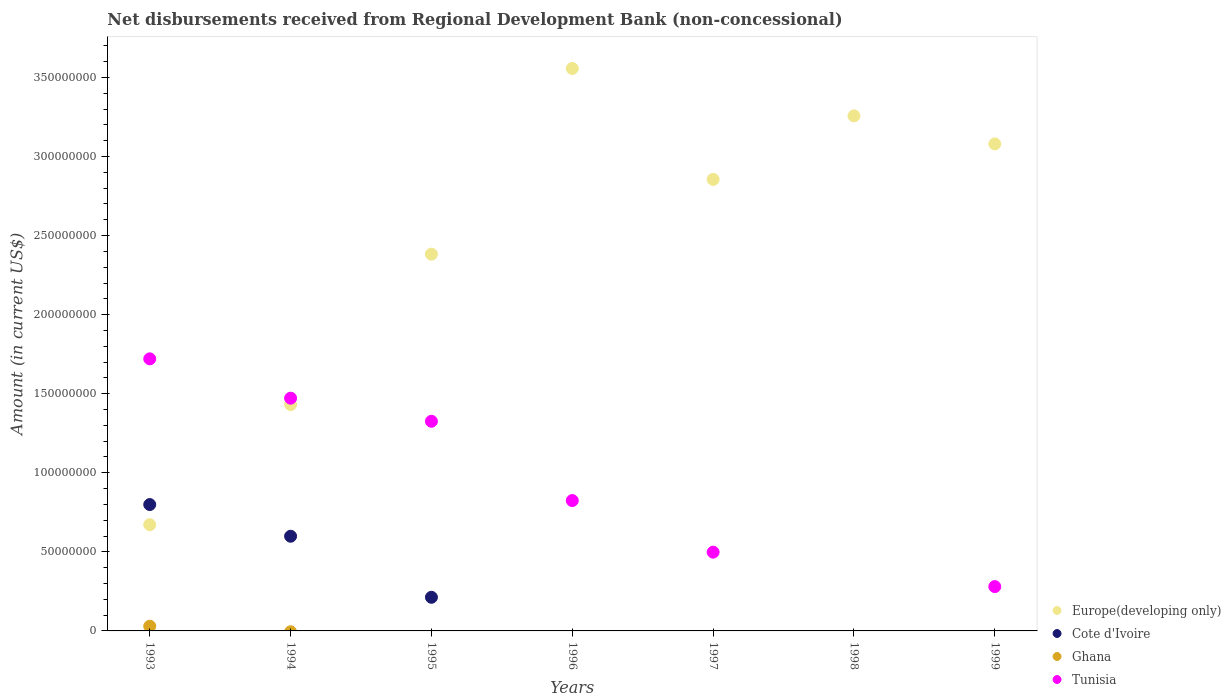Across all years, what is the maximum amount of disbursements received from Regional Development Bank in Ghana?
Your answer should be very brief. 2.98e+06. In which year was the amount of disbursements received from Regional Development Bank in Europe(developing only) maximum?
Provide a succinct answer. 1996. What is the total amount of disbursements received from Regional Development Bank in Cote d'Ivoire in the graph?
Give a very brief answer. 1.61e+08. What is the difference between the amount of disbursements received from Regional Development Bank in Europe(developing only) in 1994 and that in 1999?
Provide a succinct answer. -1.65e+08. What is the difference between the amount of disbursements received from Regional Development Bank in Cote d'Ivoire in 1993 and the amount of disbursements received from Regional Development Bank in Tunisia in 1997?
Ensure brevity in your answer.  3.01e+07. What is the average amount of disbursements received from Regional Development Bank in Tunisia per year?
Offer a terse response. 8.74e+07. In the year 1993, what is the difference between the amount of disbursements received from Regional Development Bank in Cote d'Ivoire and amount of disbursements received from Regional Development Bank in Ghana?
Offer a terse response. 7.69e+07. What is the ratio of the amount of disbursements received from Regional Development Bank in Europe(developing only) in 1997 to that in 1998?
Make the answer very short. 0.88. What is the difference between the highest and the second highest amount of disbursements received from Regional Development Bank in Tunisia?
Provide a short and direct response. 2.49e+07. What is the difference between the highest and the lowest amount of disbursements received from Regional Development Bank in Cote d'Ivoire?
Offer a very short reply. 7.99e+07. In how many years, is the amount of disbursements received from Regional Development Bank in Ghana greater than the average amount of disbursements received from Regional Development Bank in Ghana taken over all years?
Your answer should be very brief. 1. Is the sum of the amount of disbursements received from Regional Development Bank in Europe(developing only) in 1995 and 1999 greater than the maximum amount of disbursements received from Regional Development Bank in Tunisia across all years?
Your answer should be compact. Yes. Does the amount of disbursements received from Regional Development Bank in Ghana monotonically increase over the years?
Offer a terse response. No. Is the amount of disbursements received from Regional Development Bank in Ghana strictly less than the amount of disbursements received from Regional Development Bank in Tunisia over the years?
Provide a short and direct response. No. How many years are there in the graph?
Keep it short and to the point. 7. Are the values on the major ticks of Y-axis written in scientific E-notation?
Provide a short and direct response. No. Does the graph contain grids?
Offer a very short reply. No. Where does the legend appear in the graph?
Your answer should be compact. Bottom right. How many legend labels are there?
Keep it short and to the point. 4. What is the title of the graph?
Make the answer very short. Net disbursements received from Regional Development Bank (non-concessional). What is the label or title of the X-axis?
Provide a succinct answer. Years. What is the label or title of the Y-axis?
Your response must be concise. Amount (in current US$). What is the Amount (in current US$) in Europe(developing only) in 1993?
Offer a terse response. 6.72e+07. What is the Amount (in current US$) in Cote d'Ivoire in 1993?
Your answer should be very brief. 7.99e+07. What is the Amount (in current US$) in Ghana in 1993?
Provide a succinct answer. 2.98e+06. What is the Amount (in current US$) in Tunisia in 1993?
Make the answer very short. 1.72e+08. What is the Amount (in current US$) of Europe(developing only) in 1994?
Your answer should be very brief. 1.43e+08. What is the Amount (in current US$) of Cote d'Ivoire in 1994?
Offer a very short reply. 5.99e+07. What is the Amount (in current US$) of Tunisia in 1994?
Make the answer very short. 1.47e+08. What is the Amount (in current US$) of Europe(developing only) in 1995?
Provide a succinct answer. 2.38e+08. What is the Amount (in current US$) of Cote d'Ivoire in 1995?
Your response must be concise. 2.13e+07. What is the Amount (in current US$) of Ghana in 1995?
Offer a terse response. 0. What is the Amount (in current US$) in Tunisia in 1995?
Offer a terse response. 1.33e+08. What is the Amount (in current US$) in Europe(developing only) in 1996?
Make the answer very short. 3.56e+08. What is the Amount (in current US$) of Ghana in 1996?
Keep it short and to the point. 0. What is the Amount (in current US$) of Tunisia in 1996?
Provide a succinct answer. 8.24e+07. What is the Amount (in current US$) of Europe(developing only) in 1997?
Offer a terse response. 2.86e+08. What is the Amount (in current US$) in Cote d'Ivoire in 1997?
Keep it short and to the point. 0. What is the Amount (in current US$) in Ghana in 1997?
Your answer should be very brief. 0. What is the Amount (in current US$) in Tunisia in 1997?
Provide a succinct answer. 4.98e+07. What is the Amount (in current US$) of Europe(developing only) in 1998?
Offer a very short reply. 3.26e+08. What is the Amount (in current US$) in Cote d'Ivoire in 1998?
Offer a terse response. 0. What is the Amount (in current US$) of Europe(developing only) in 1999?
Your response must be concise. 3.08e+08. What is the Amount (in current US$) in Cote d'Ivoire in 1999?
Keep it short and to the point. 0. What is the Amount (in current US$) of Tunisia in 1999?
Your answer should be compact. 2.80e+07. Across all years, what is the maximum Amount (in current US$) of Europe(developing only)?
Ensure brevity in your answer.  3.56e+08. Across all years, what is the maximum Amount (in current US$) of Cote d'Ivoire?
Offer a very short reply. 7.99e+07. Across all years, what is the maximum Amount (in current US$) of Ghana?
Provide a short and direct response. 2.98e+06. Across all years, what is the maximum Amount (in current US$) in Tunisia?
Give a very brief answer. 1.72e+08. Across all years, what is the minimum Amount (in current US$) in Europe(developing only)?
Offer a very short reply. 6.72e+07. What is the total Amount (in current US$) in Europe(developing only) in the graph?
Provide a succinct answer. 1.72e+09. What is the total Amount (in current US$) of Cote d'Ivoire in the graph?
Give a very brief answer. 1.61e+08. What is the total Amount (in current US$) in Ghana in the graph?
Ensure brevity in your answer.  2.98e+06. What is the total Amount (in current US$) in Tunisia in the graph?
Your answer should be very brief. 6.12e+08. What is the difference between the Amount (in current US$) in Europe(developing only) in 1993 and that in 1994?
Provide a short and direct response. -7.60e+07. What is the difference between the Amount (in current US$) in Cote d'Ivoire in 1993 and that in 1994?
Provide a succinct answer. 2.00e+07. What is the difference between the Amount (in current US$) in Tunisia in 1993 and that in 1994?
Keep it short and to the point. 2.49e+07. What is the difference between the Amount (in current US$) of Europe(developing only) in 1993 and that in 1995?
Your answer should be very brief. -1.71e+08. What is the difference between the Amount (in current US$) of Cote d'Ivoire in 1993 and that in 1995?
Make the answer very short. 5.86e+07. What is the difference between the Amount (in current US$) of Tunisia in 1993 and that in 1995?
Keep it short and to the point. 3.95e+07. What is the difference between the Amount (in current US$) in Europe(developing only) in 1993 and that in 1996?
Keep it short and to the point. -2.88e+08. What is the difference between the Amount (in current US$) in Tunisia in 1993 and that in 1996?
Keep it short and to the point. 8.96e+07. What is the difference between the Amount (in current US$) of Europe(developing only) in 1993 and that in 1997?
Your answer should be compact. -2.18e+08. What is the difference between the Amount (in current US$) of Tunisia in 1993 and that in 1997?
Offer a terse response. 1.22e+08. What is the difference between the Amount (in current US$) in Europe(developing only) in 1993 and that in 1998?
Provide a short and direct response. -2.59e+08. What is the difference between the Amount (in current US$) of Europe(developing only) in 1993 and that in 1999?
Keep it short and to the point. -2.41e+08. What is the difference between the Amount (in current US$) of Tunisia in 1993 and that in 1999?
Provide a short and direct response. 1.44e+08. What is the difference between the Amount (in current US$) in Europe(developing only) in 1994 and that in 1995?
Your answer should be compact. -9.51e+07. What is the difference between the Amount (in current US$) of Cote d'Ivoire in 1994 and that in 1995?
Your answer should be very brief. 3.86e+07. What is the difference between the Amount (in current US$) in Tunisia in 1994 and that in 1995?
Keep it short and to the point. 1.46e+07. What is the difference between the Amount (in current US$) in Europe(developing only) in 1994 and that in 1996?
Your answer should be compact. -2.13e+08. What is the difference between the Amount (in current US$) of Tunisia in 1994 and that in 1996?
Ensure brevity in your answer.  6.47e+07. What is the difference between the Amount (in current US$) in Europe(developing only) in 1994 and that in 1997?
Give a very brief answer. -1.42e+08. What is the difference between the Amount (in current US$) of Tunisia in 1994 and that in 1997?
Offer a very short reply. 9.74e+07. What is the difference between the Amount (in current US$) of Europe(developing only) in 1994 and that in 1998?
Offer a very short reply. -1.83e+08. What is the difference between the Amount (in current US$) of Europe(developing only) in 1994 and that in 1999?
Give a very brief answer. -1.65e+08. What is the difference between the Amount (in current US$) of Tunisia in 1994 and that in 1999?
Ensure brevity in your answer.  1.19e+08. What is the difference between the Amount (in current US$) in Europe(developing only) in 1995 and that in 1996?
Keep it short and to the point. -1.17e+08. What is the difference between the Amount (in current US$) in Tunisia in 1995 and that in 1996?
Give a very brief answer. 5.01e+07. What is the difference between the Amount (in current US$) in Europe(developing only) in 1995 and that in 1997?
Give a very brief answer. -4.73e+07. What is the difference between the Amount (in current US$) in Tunisia in 1995 and that in 1997?
Offer a terse response. 8.28e+07. What is the difference between the Amount (in current US$) of Europe(developing only) in 1995 and that in 1998?
Provide a short and direct response. -8.75e+07. What is the difference between the Amount (in current US$) of Europe(developing only) in 1995 and that in 1999?
Provide a short and direct response. -6.97e+07. What is the difference between the Amount (in current US$) in Tunisia in 1995 and that in 1999?
Make the answer very short. 1.05e+08. What is the difference between the Amount (in current US$) of Europe(developing only) in 1996 and that in 1997?
Ensure brevity in your answer.  7.01e+07. What is the difference between the Amount (in current US$) of Tunisia in 1996 and that in 1997?
Offer a very short reply. 3.26e+07. What is the difference between the Amount (in current US$) in Europe(developing only) in 1996 and that in 1998?
Ensure brevity in your answer.  3.00e+07. What is the difference between the Amount (in current US$) in Europe(developing only) in 1996 and that in 1999?
Your answer should be compact. 4.77e+07. What is the difference between the Amount (in current US$) in Tunisia in 1996 and that in 1999?
Offer a very short reply. 5.44e+07. What is the difference between the Amount (in current US$) in Europe(developing only) in 1997 and that in 1998?
Your answer should be compact. -4.02e+07. What is the difference between the Amount (in current US$) of Europe(developing only) in 1997 and that in 1999?
Offer a terse response. -2.24e+07. What is the difference between the Amount (in current US$) in Tunisia in 1997 and that in 1999?
Provide a short and direct response. 2.18e+07. What is the difference between the Amount (in current US$) in Europe(developing only) in 1998 and that in 1999?
Your answer should be compact. 1.77e+07. What is the difference between the Amount (in current US$) of Europe(developing only) in 1993 and the Amount (in current US$) of Cote d'Ivoire in 1994?
Give a very brief answer. 7.30e+06. What is the difference between the Amount (in current US$) in Europe(developing only) in 1993 and the Amount (in current US$) in Tunisia in 1994?
Offer a terse response. -8.00e+07. What is the difference between the Amount (in current US$) of Cote d'Ivoire in 1993 and the Amount (in current US$) of Tunisia in 1994?
Your answer should be very brief. -6.73e+07. What is the difference between the Amount (in current US$) of Ghana in 1993 and the Amount (in current US$) of Tunisia in 1994?
Your response must be concise. -1.44e+08. What is the difference between the Amount (in current US$) in Europe(developing only) in 1993 and the Amount (in current US$) in Cote d'Ivoire in 1995?
Offer a very short reply. 4.59e+07. What is the difference between the Amount (in current US$) of Europe(developing only) in 1993 and the Amount (in current US$) of Tunisia in 1995?
Offer a terse response. -6.54e+07. What is the difference between the Amount (in current US$) of Cote d'Ivoire in 1993 and the Amount (in current US$) of Tunisia in 1995?
Keep it short and to the point. -5.27e+07. What is the difference between the Amount (in current US$) in Ghana in 1993 and the Amount (in current US$) in Tunisia in 1995?
Make the answer very short. -1.30e+08. What is the difference between the Amount (in current US$) in Europe(developing only) in 1993 and the Amount (in current US$) in Tunisia in 1996?
Provide a short and direct response. -1.53e+07. What is the difference between the Amount (in current US$) of Cote d'Ivoire in 1993 and the Amount (in current US$) of Tunisia in 1996?
Make the answer very short. -2.53e+06. What is the difference between the Amount (in current US$) of Ghana in 1993 and the Amount (in current US$) of Tunisia in 1996?
Provide a succinct answer. -7.95e+07. What is the difference between the Amount (in current US$) in Europe(developing only) in 1993 and the Amount (in current US$) in Tunisia in 1997?
Give a very brief answer. 1.74e+07. What is the difference between the Amount (in current US$) in Cote d'Ivoire in 1993 and the Amount (in current US$) in Tunisia in 1997?
Your answer should be very brief. 3.01e+07. What is the difference between the Amount (in current US$) in Ghana in 1993 and the Amount (in current US$) in Tunisia in 1997?
Give a very brief answer. -4.68e+07. What is the difference between the Amount (in current US$) of Europe(developing only) in 1993 and the Amount (in current US$) of Tunisia in 1999?
Your answer should be very brief. 3.92e+07. What is the difference between the Amount (in current US$) in Cote d'Ivoire in 1993 and the Amount (in current US$) in Tunisia in 1999?
Offer a very short reply. 5.19e+07. What is the difference between the Amount (in current US$) of Ghana in 1993 and the Amount (in current US$) of Tunisia in 1999?
Your response must be concise. -2.50e+07. What is the difference between the Amount (in current US$) in Europe(developing only) in 1994 and the Amount (in current US$) in Cote d'Ivoire in 1995?
Your response must be concise. 1.22e+08. What is the difference between the Amount (in current US$) of Europe(developing only) in 1994 and the Amount (in current US$) of Tunisia in 1995?
Your answer should be compact. 1.06e+07. What is the difference between the Amount (in current US$) of Cote d'Ivoire in 1994 and the Amount (in current US$) of Tunisia in 1995?
Provide a succinct answer. -7.27e+07. What is the difference between the Amount (in current US$) of Europe(developing only) in 1994 and the Amount (in current US$) of Tunisia in 1996?
Provide a succinct answer. 6.07e+07. What is the difference between the Amount (in current US$) in Cote d'Ivoire in 1994 and the Amount (in current US$) in Tunisia in 1996?
Give a very brief answer. -2.26e+07. What is the difference between the Amount (in current US$) of Europe(developing only) in 1994 and the Amount (in current US$) of Tunisia in 1997?
Offer a very short reply. 9.33e+07. What is the difference between the Amount (in current US$) of Cote d'Ivoire in 1994 and the Amount (in current US$) of Tunisia in 1997?
Your answer should be compact. 1.01e+07. What is the difference between the Amount (in current US$) of Europe(developing only) in 1994 and the Amount (in current US$) of Tunisia in 1999?
Provide a short and direct response. 1.15e+08. What is the difference between the Amount (in current US$) in Cote d'Ivoire in 1994 and the Amount (in current US$) in Tunisia in 1999?
Your response must be concise. 3.19e+07. What is the difference between the Amount (in current US$) of Europe(developing only) in 1995 and the Amount (in current US$) of Tunisia in 1996?
Offer a very short reply. 1.56e+08. What is the difference between the Amount (in current US$) of Cote d'Ivoire in 1995 and the Amount (in current US$) of Tunisia in 1996?
Your response must be concise. -6.12e+07. What is the difference between the Amount (in current US$) in Europe(developing only) in 1995 and the Amount (in current US$) in Tunisia in 1997?
Your answer should be compact. 1.88e+08. What is the difference between the Amount (in current US$) in Cote d'Ivoire in 1995 and the Amount (in current US$) in Tunisia in 1997?
Ensure brevity in your answer.  -2.85e+07. What is the difference between the Amount (in current US$) of Europe(developing only) in 1995 and the Amount (in current US$) of Tunisia in 1999?
Your answer should be very brief. 2.10e+08. What is the difference between the Amount (in current US$) of Cote d'Ivoire in 1995 and the Amount (in current US$) of Tunisia in 1999?
Make the answer very short. -6.76e+06. What is the difference between the Amount (in current US$) of Europe(developing only) in 1996 and the Amount (in current US$) of Tunisia in 1997?
Your answer should be compact. 3.06e+08. What is the difference between the Amount (in current US$) in Europe(developing only) in 1996 and the Amount (in current US$) in Tunisia in 1999?
Your answer should be compact. 3.28e+08. What is the difference between the Amount (in current US$) of Europe(developing only) in 1997 and the Amount (in current US$) of Tunisia in 1999?
Offer a very short reply. 2.58e+08. What is the difference between the Amount (in current US$) of Europe(developing only) in 1998 and the Amount (in current US$) of Tunisia in 1999?
Offer a terse response. 2.98e+08. What is the average Amount (in current US$) of Europe(developing only) per year?
Your answer should be compact. 2.46e+08. What is the average Amount (in current US$) in Cote d'Ivoire per year?
Make the answer very short. 2.30e+07. What is the average Amount (in current US$) of Ghana per year?
Ensure brevity in your answer.  4.25e+05. What is the average Amount (in current US$) in Tunisia per year?
Provide a short and direct response. 8.74e+07. In the year 1993, what is the difference between the Amount (in current US$) in Europe(developing only) and Amount (in current US$) in Cote d'Ivoire?
Provide a succinct answer. -1.27e+07. In the year 1993, what is the difference between the Amount (in current US$) in Europe(developing only) and Amount (in current US$) in Ghana?
Make the answer very short. 6.42e+07. In the year 1993, what is the difference between the Amount (in current US$) of Europe(developing only) and Amount (in current US$) of Tunisia?
Your answer should be compact. -1.05e+08. In the year 1993, what is the difference between the Amount (in current US$) in Cote d'Ivoire and Amount (in current US$) in Ghana?
Provide a succinct answer. 7.69e+07. In the year 1993, what is the difference between the Amount (in current US$) in Cote d'Ivoire and Amount (in current US$) in Tunisia?
Your answer should be very brief. -9.21e+07. In the year 1993, what is the difference between the Amount (in current US$) of Ghana and Amount (in current US$) of Tunisia?
Provide a short and direct response. -1.69e+08. In the year 1994, what is the difference between the Amount (in current US$) in Europe(developing only) and Amount (in current US$) in Cote d'Ivoire?
Offer a very short reply. 8.33e+07. In the year 1994, what is the difference between the Amount (in current US$) of Europe(developing only) and Amount (in current US$) of Tunisia?
Offer a very short reply. -4.04e+06. In the year 1994, what is the difference between the Amount (in current US$) of Cote d'Ivoire and Amount (in current US$) of Tunisia?
Your answer should be very brief. -8.73e+07. In the year 1995, what is the difference between the Amount (in current US$) in Europe(developing only) and Amount (in current US$) in Cote d'Ivoire?
Provide a short and direct response. 2.17e+08. In the year 1995, what is the difference between the Amount (in current US$) in Europe(developing only) and Amount (in current US$) in Tunisia?
Provide a succinct answer. 1.06e+08. In the year 1995, what is the difference between the Amount (in current US$) of Cote d'Ivoire and Amount (in current US$) of Tunisia?
Provide a succinct answer. -1.11e+08. In the year 1996, what is the difference between the Amount (in current US$) of Europe(developing only) and Amount (in current US$) of Tunisia?
Offer a terse response. 2.73e+08. In the year 1997, what is the difference between the Amount (in current US$) of Europe(developing only) and Amount (in current US$) of Tunisia?
Ensure brevity in your answer.  2.36e+08. In the year 1999, what is the difference between the Amount (in current US$) of Europe(developing only) and Amount (in current US$) of Tunisia?
Your answer should be compact. 2.80e+08. What is the ratio of the Amount (in current US$) in Europe(developing only) in 1993 to that in 1994?
Ensure brevity in your answer.  0.47. What is the ratio of the Amount (in current US$) in Cote d'Ivoire in 1993 to that in 1994?
Ensure brevity in your answer.  1.33. What is the ratio of the Amount (in current US$) in Tunisia in 1993 to that in 1994?
Ensure brevity in your answer.  1.17. What is the ratio of the Amount (in current US$) in Europe(developing only) in 1993 to that in 1995?
Your response must be concise. 0.28. What is the ratio of the Amount (in current US$) of Cote d'Ivoire in 1993 to that in 1995?
Your answer should be compact. 3.76. What is the ratio of the Amount (in current US$) of Tunisia in 1993 to that in 1995?
Keep it short and to the point. 1.3. What is the ratio of the Amount (in current US$) in Europe(developing only) in 1993 to that in 1996?
Your answer should be compact. 0.19. What is the ratio of the Amount (in current US$) in Tunisia in 1993 to that in 1996?
Your answer should be very brief. 2.09. What is the ratio of the Amount (in current US$) in Europe(developing only) in 1993 to that in 1997?
Your answer should be compact. 0.24. What is the ratio of the Amount (in current US$) of Tunisia in 1993 to that in 1997?
Keep it short and to the point. 3.45. What is the ratio of the Amount (in current US$) in Europe(developing only) in 1993 to that in 1998?
Make the answer very short. 0.21. What is the ratio of the Amount (in current US$) of Europe(developing only) in 1993 to that in 1999?
Your answer should be very brief. 0.22. What is the ratio of the Amount (in current US$) of Tunisia in 1993 to that in 1999?
Provide a succinct answer. 6.14. What is the ratio of the Amount (in current US$) of Europe(developing only) in 1994 to that in 1995?
Your answer should be very brief. 0.6. What is the ratio of the Amount (in current US$) of Cote d'Ivoire in 1994 to that in 1995?
Provide a short and direct response. 2.82. What is the ratio of the Amount (in current US$) in Tunisia in 1994 to that in 1995?
Offer a very short reply. 1.11. What is the ratio of the Amount (in current US$) of Europe(developing only) in 1994 to that in 1996?
Your answer should be compact. 0.4. What is the ratio of the Amount (in current US$) of Tunisia in 1994 to that in 1996?
Your answer should be very brief. 1.79. What is the ratio of the Amount (in current US$) in Europe(developing only) in 1994 to that in 1997?
Your answer should be very brief. 0.5. What is the ratio of the Amount (in current US$) of Tunisia in 1994 to that in 1997?
Your answer should be very brief. 2.96. What is the ratio of the Amount (in current US$) in Europe(developing only) in 1994 to that in 1998?
Make the answer very short. 0.44. What is the ratio of the Amount (in current US$) of Europe(developing only) in 1994 to that in 1999?
Your answer should be compact. 0.46. What is the ratio of the Amount (in current US$) in Tunisia in 1994 to that in 1999?
Offer a very short reply. 5.25. What is the ratio of the Amount (in current US$) of Europe(developing only) in 1995 to that in 1996?
Make the answer very short. 0.67. What is the ratio of the Amount (in current US$) of Tunisia in 1995 to that in 1996?
Keep it short and to the point. 1.61. What is the ratio of the Amount (in current US$) of Europe(developing only) in 1995 to that in 1997?
Offer a terse response. 0.83. What is the ratio of the Amount (in current US$) in Tunisia in 1995 to that in 1997?
Your answer should be compact. 2.66. What is the ratio of the Amount (in current US$) in Europe(developing only) in 1995 to that in 1998?
Provide a short and direct response. 0.73. What is the ratio of the Amount (in current US$) in Europe(developing only) in 1995 to that in 1999?
Your answer should be very brief. 0.77. What is the ratio of the Amount (in current US$) of Tunisia in 1995 to that in 1999?
Your answer should be compact. 4.73. What is the ratio of the Amount (in current US$) in Europe(developing only) in 1996 to that in 1997?
Your response must be concise. 1.25. What is the ratio of the Amount (in current US$) of Tunisia in 1996 to that in 1997?
Keep it short and to the point. 1.66. What is the ratio of the Amount (in current US$) of Europe(developing only) in 1996 to that in 1998?
Keep it short and to the point. 1.09. What is the ratio of the Amount (in current US$) of Europe(developing only) in 1996 to that in 1999?
Make the answer very short. 1.15. What is the ratio of the Amount (in current US$) of Tunisia in 1996 to that in 1999?
Give a very brief answer. 2.94. What is the ratio of the Amount (in current US$) of Europe(developing only) in 1997 to that in 1998?
Make the answer very short. 0.88. What is the ratio of the Amount (in current US$) of Europe(developing only) in 1997 to that in 1999?
Your response must be concise. 0.93. What is the ratio of the Amount (in current US$) in Tunisia in 1997 to that in 1999?
Your answer should be compact. 1.78. What is the ratio of the Amount (in current US$) in Europe(developing only) in 1998 to that in 1999?
Your response must be concise. 1.06. What is the difference between the highest and the second highest Amount (in current US$) of Europe(developing only)?
Your answer should be very brief. 3.00e+07. What is the difference between the highest and the second highest Amount (in current US$) in Cote d'Ivoire?
Offer a terse response. 2.00e+07. What is the difference between the highest and the second highest Amount (in current US$) in Tunisia?
Give a very brief answer. 2.49e+07. What is the difference between the highest and the lowest Amount (in current US$) of Europe(developing only)?
Ensure brevity in your answer.  2.88e+08. What is the difference between the highest and the lowest Amount (in current US$) of Cote d'Ivoire?
Your answer should be compact. 7.99e+07. What is the difference between the highest and the lowest Amount (in current US$) of Ghana?
Provide a succinct answer. 2.98e+06. What is the difference between the highest and the lowest Amount (in current US$) in Tunisia?
Your answer should be compact. 1.72e+08. 